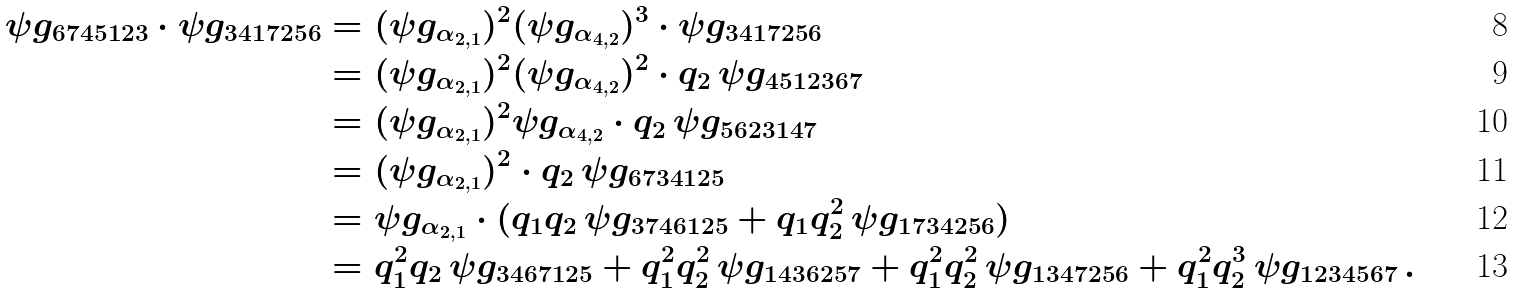<formula> <loc_0><loc_0><loc_500><loc_500>\psi g _ { 6 7 4 5 1 2 3 } \cdot \psi g _ { 3 4 1 7 2 5 6 } & = ( \psi g _ { \alpha _ { 2 , 1 } } ) ^ { 2 } ( \psi g _ { \alpha _ { 4 , 2 } } ) ^ { 3 } \cdot \psi g _ { 3 4 1 7 2 5 6 } \\ & = ( \psi g _ { \alpha _ { 2 , 1 } } ) ^ { 2 } ( \psi g _ { \alpha _ { 4 , 2 } } ) ^ { 2 } \cdot q _ { 2 } \, \psi g _ { 4 5 1 2 3 6 7 } \\ & = ( \psi g _ { \alpha _ { 2 , 1 } } ) ^ { 2 } \psi g _ { \alpha _ { 4 , 2 } } \cdot q _ { 2 } \, \psi g _ { 5 6 2 3 1 4 7 } \\ & = ( \psi g _ { \alpha _ { 2 , 1 } } ) ^ { 2 } \cdot q _ { 2 } \, \psi g _ { 6 7 3 4 1 2 5 } \\ & = \psi g _ { \alpha _ { 2 , 1 } } \cdot ( q _ { 1 } q _ { 2 } \, \psi g _ { 3 7 4 6 1 2 5 } + q _ { 1 } q _ { 2 } ^ { 2 } \, \psi g _ { 1 7 3 4 2 5 6 } ) \\ & = q _ { 1 } ^ { 2 } q _ { 2 } \, \psi g _ { 3 4 6 7 1 2 5 } + q _ { 1 } ^ { 2 } q _ { 2 } ^ { 2 } \, \psi g _ { 1 4 3 6 2 5 7 } + q _ { 1 } ^ { 2 } q _ { 2 } ^ { 2 } \, \psi g _ { 1 3 4 7 2 5 6 } + q _ { 1 } ^ { 2 } q _ { 2 } ^ { 3 } \, \psi g _ { 1 2 3 4 5 6 7 } \, .</formula> 